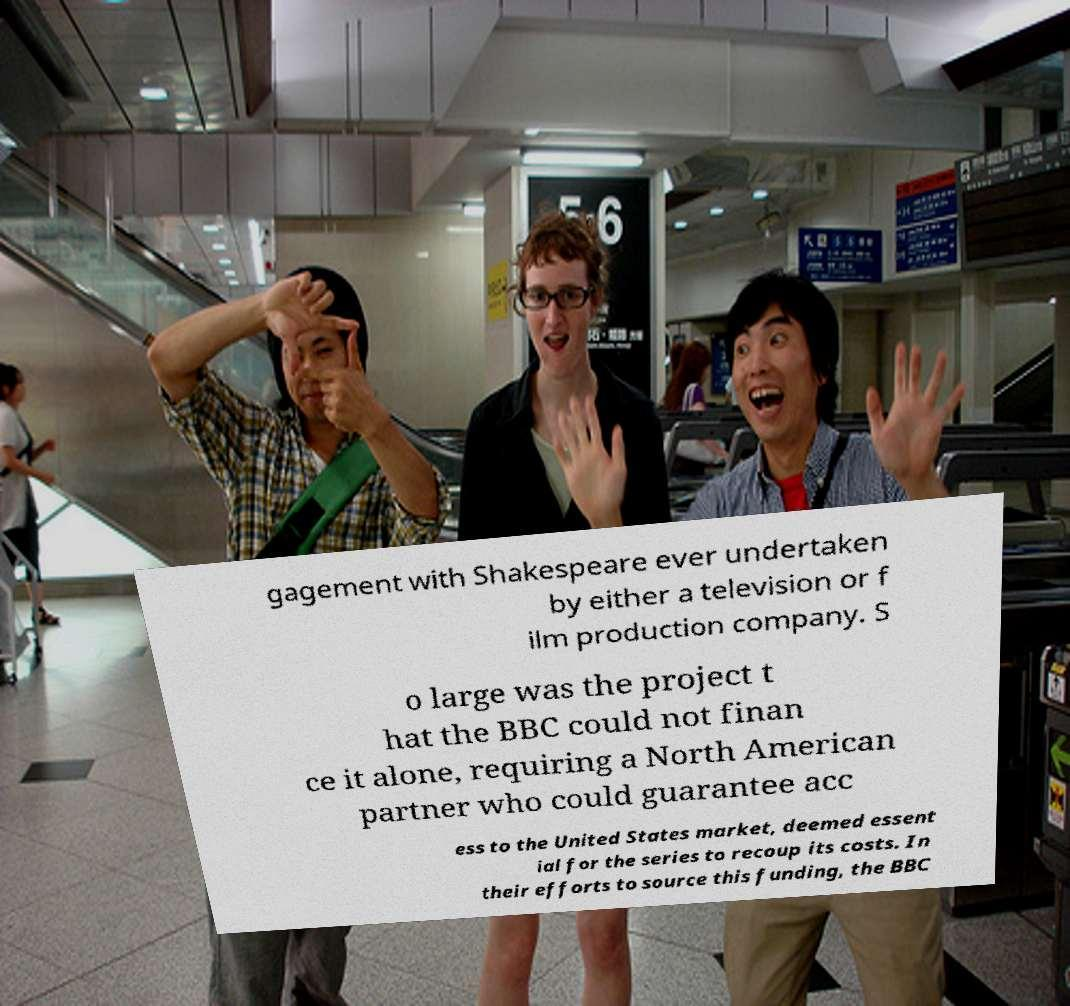Please read and relay the text visible in this image. What does it say? gagement with Shakespeare ever undertaken by either a television or f ilm production company. S o large was the project t hat the BBC could not finan ce it alone, requiring a North American partner who could guarantee acc ess to the United States market, deemed essent ial for the series to recoup its costs. In their efforts to source this funding, the BBC 